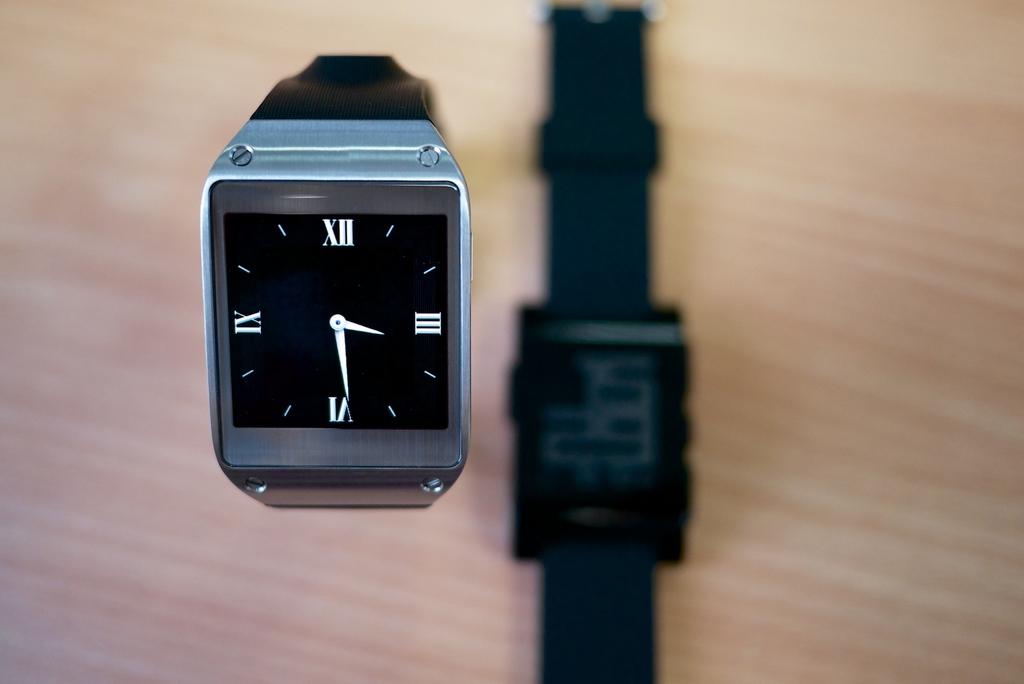What is the time on the watch?
Your answer should be compact. 3:29. What number is the minute watch hand on?
Provide a short and direct response. 6. 